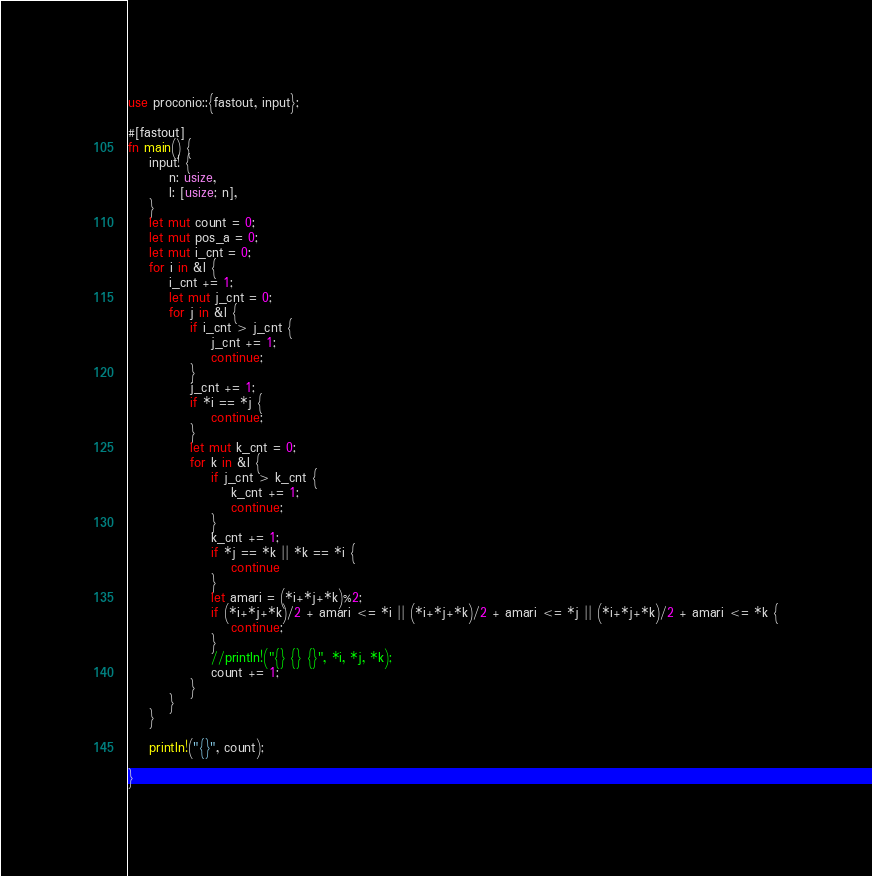Convert code to text. <code><loc_0><loc_0><loc_500><loc_500><_Rust_>use proconio::{fastout, input};

#[fastout]
fn main() {
    input! {
        n: usize,
        l: [usize; n],
    }
    let mut count = 0;
    let mut pos_a = 0;
    let mut i_cnt = 0;
    for i in &l {
        i_cnt += 1;
        let mut j_cnt = 0;
        for j in &l {
            if i_cnt > j_cnt {
                j_cnt += 1;
                continue;
            }
            j_cnt += 1;
            if *i == *j {
                continue;
            }
            let mut k_cnt = 0;
            for k in &l {
                if j_cnt > k_cnt {
                    k_cnt += 1;
                    continue;
                }
                k_cnt += 1;
                if *j == *k || *k == *i {
                    continue
                }
                let amari = (*i+*j+*k)%2;
                if (*i+*j+*k)/2 + amari <= *i || (*i+*j+*k)/2 + amari <= *j || (*i+*j+*k)/2 + amari <= *k {
                    continue;
                }
                //println!("{} {} {}", *i, *j, *k);
                count += 1;
            }
        }
    }

    println!("{}", count);
    
}
</code> 